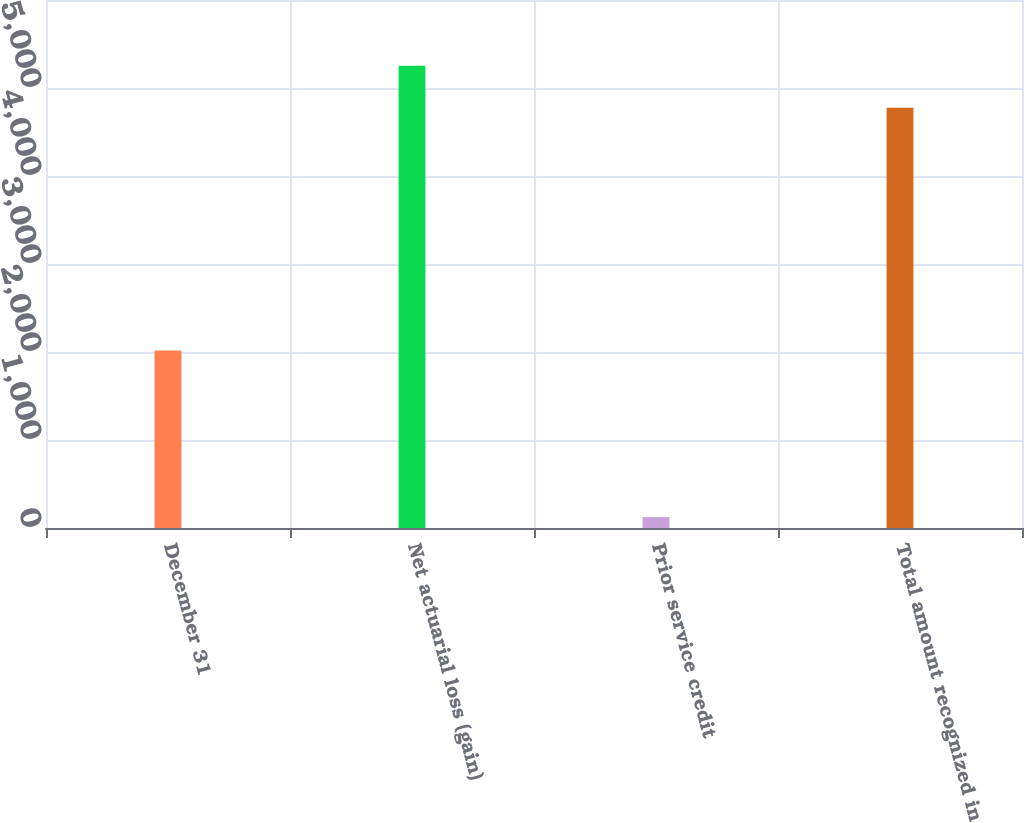Convert chart to OTSL. <chart><loc_0><loc_0><loc_500><loc_500><bar_chart><fcel>December 31<fcel>Net actuarial loss (gain)<fcel>Prior service credit<fcel>Total amount recognized in<nl><fcel>2017<fcel>5252.5<fcel>124<fcel>4775<nl></chart> 